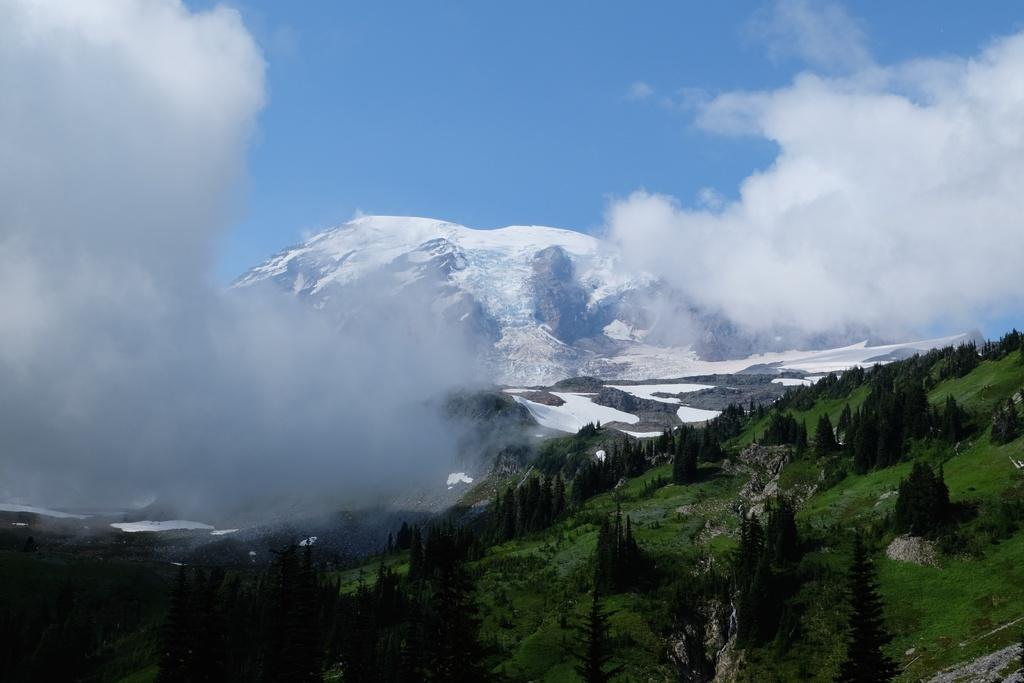What type of natural features can be seen in the image? There are trees and mountains in the image. What is visible in the background of the image? The sky is visible in the image. What can be seen in the sky in the image? Clouds are present in the image. What type of copper material can be seen in the image? There is no copper material present in the image. How many dogs are visible in the image? There are no dogs present in the image. 